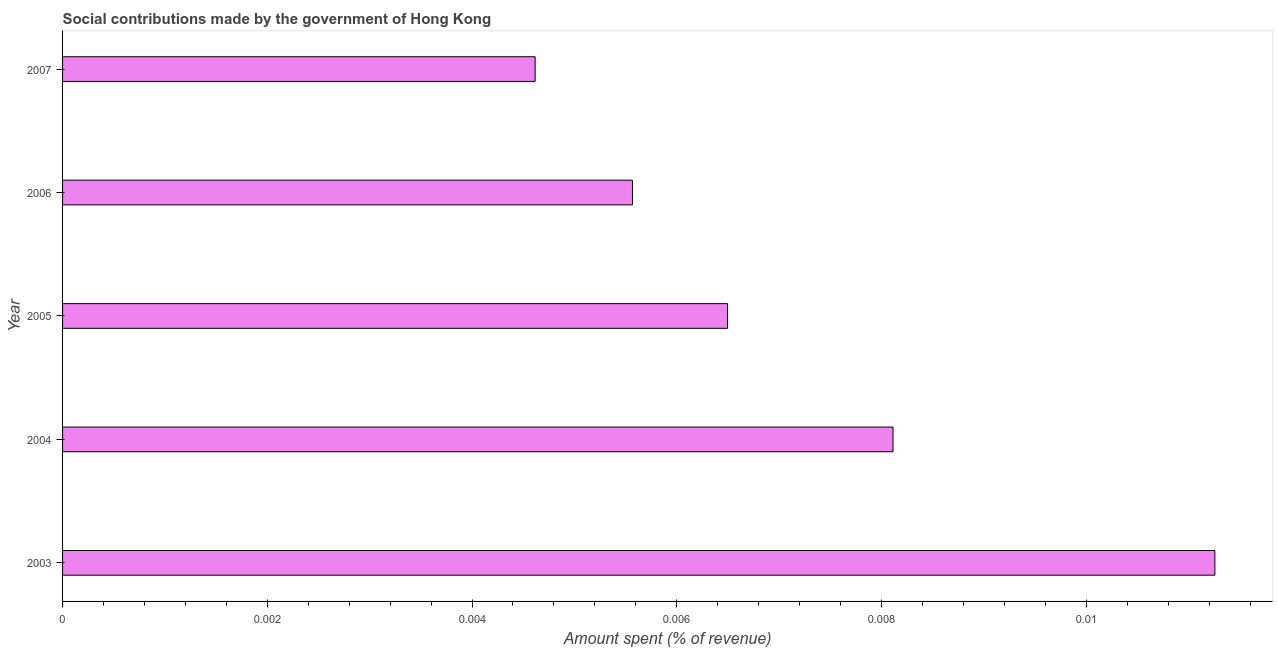What is the title of the graph?
Your answer should be very brief. Social contributions made by the government of Hong Kong. What is the label or title of the X-axis?
Give a very brief answer. Amount spent (% of revenue). What is the amount spent in making social contributions in 2004?
Keep it short and to the point. 0.01. Across all years, what is the maximum amount spent in making social contributions?
Offer a terse response. 0.01. Across all years, what is the minimum amount spent in making social contributions?
Your response must be concise. 0. In which year was the amount spent in making social contributions maximum?
Provide a succinct answer. 2003. What is the sum of the amount spent in making social contributions?
Give a very brief answer. 0.04. What is the average amount spent in making social contributions per year?
Give a very brief answer. 0.01. What is the median amount spent in making social contributions?
Your answer should be very brief. 0.01. What is the ratio of the amount spent in making social contributions in 2003 to that in 2007?
Make the answer very short. 2.44. Is the amount spent in making social contributions in 2004 less than that in 2006?
Your answer should be compact. No. What is the difference between the highest and the second highest amount spent in making social contributions?
Your answer should be compact. 0. What is the difference between the highest and the lowest amount spent in making social contributions?
Offer a very short reply. 0.01. How many bars are there?
Your response must be concise. 5. What is the difference between two consecutive major ticks on the X-axis?
Your answer should be very brief. 0. What is the Amount spent (% of revenue) of 2003?
Offer a very short reply. 0.01. What is the Amount spent (% of revenue) of 2004?
Keep it short and to the point. 0.01. What is the Amount spent (% of revenue) in 2005?
Make the answer very short. 0.01. What is the Amount spent (% of revenue) of 2006?
Offer a very short reply. 0.01. What is the Amount spent (% of revenue) in 2007?
Ensure brevity in your answer.  0. What is the difference between the Amount spent (% of revenue) in 2003 and 2004?
Your answer should be very brief. 0. What is the difference between the Amount spent (% of revenue) in 2003 and 2005?
Provide a short and direct response. 0. What is the difference between the Amount spent (% of revenue) in 2003 and 2006?
Offer a terse response. 0.01. What is the difference between the Amount spent (% of revenue) in 2003 and 2007?
Provide a succinct answer. 0.01. What is the difference between the Amount spent (% of revenue) in 2004 and 2005?
Your response must be concise. 0. What is the difference between the Amount spent (% of revenue) in 2004 and 2006?
Offer a terse response. 0. What is the difference between the Amount spent (% of revenue) in 2004 and 2007?
Provide a short and direct response. 0. What is the difference between the Amount spent (% of revenue) in 2005 and 2006?
Give a very brief answer. 0. What is the difference between the Amount spent (% of revenue) in 2005 and 2007?
Provide a succinct answer. 0. What is the difference between the Amount spent (% of revenue) in 2006 and 2007?
Your answer should be very brief. 0. What is the ratio of the Amount spent (% of revenue) in 2003 to that in 2004?
Your answer should be compact. 1.39. What is the ratio of the Amount spent (% of revenue) in 2003 to that in 2005?
Keep it short and to the point. 1.73. What is the ratio of the Amount spent (% of revenue) in 2003 to that in 2006?
Keep it short and to the point. 2.02. What is the ratio of the Amount spent (% of revenue) in 2003 to that in 2007?
Your answer should be very brief. 2.44. What is the ratio of the Amount spent (% of revenue) in 2004 to that in 2005?
Make the answer very short. 1.25. What is the ratio of the Amount spent (% of revenue) in 2004 to that in 2006?
Give a very brief answer. 1.46. What is the ratio of the Amount spent (% of revenue) in 2004 to that in 2007?
Keep it short and to the point. 1.76. What is the ratio of the Amount spent (% of revenue) in 2005 to that in 2006?
Your response must be concise. 1.17. What is the ratio of the Amount spent (% of revenue) in 2005 to that in 2007?
Offer a terse response. 1.41. What is the ratio of the Amount spent (% of revenue) in 2006 to that in 2007?
Provide a short and direct response. 1.21. 